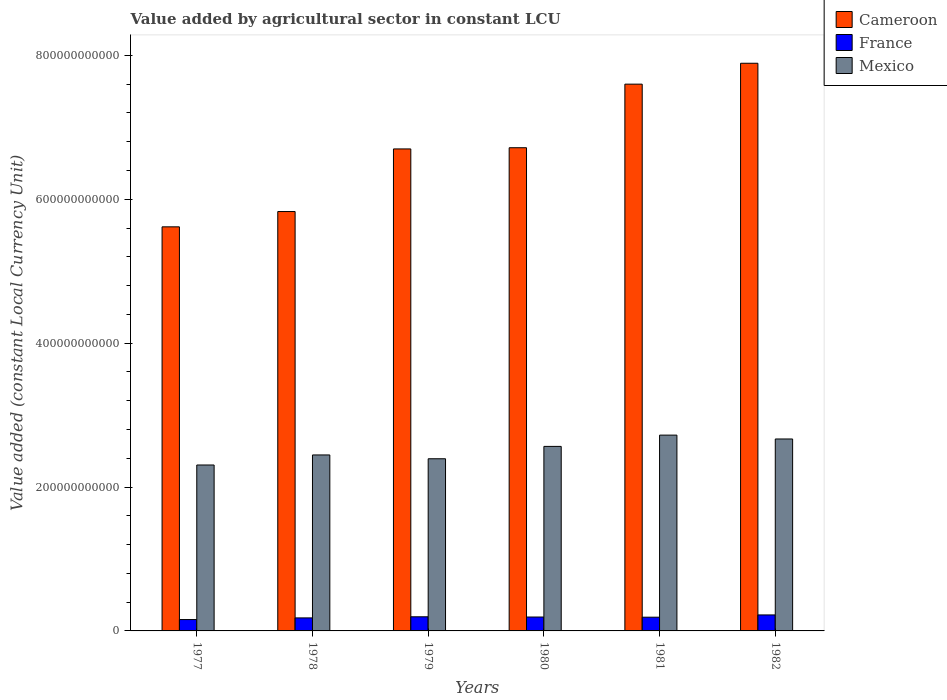Are the number of bars per tick equal to the number of legend labels?
Offer a very short reply. Yes. What is the label of the 5th group of bars from the left?
Your answer should be very brief. 1981. What is the value added by agricultural sector in France in 1980?
Your response must be concise. 1.93e+1. Across all years, what is the maximum value added by agricultural sector in Mexico?
Your answer should be compact. 2.72e+11. Across all years, what is the minimum value added by agricultural sector in Cameroon?
Offer a terse response. 5.62e+11. In which year was the value added by agricultural sector in Cameroon maximum?
Your answer should be compact. 1982. In which year was the value added by agricultural sector in Cameroon minimum?
Give a very brief answer. 1977. What is the total value added by agricultural sector in Cameroon in the graph?
Offer a terse response. 4.04e+12. What is the difference between the value added by agricultural sector in France in 1978 and that in 1982?
Your answer should be compact. -4.13e+09. What is the difference between the value added by agricultural sector in Mexico in 1982 and the value added by agricultural sector in Cameroon in 1978?
Provide a short and direct response. -3.16e+11. What is the average value added by agricultural sector in France per year?
Your response must be concise. 1.90e+1. In the year 1980, what is the difference between the value added by agricultural sector in France and value added by agricultural sector in Mexico?
Provide a succinct answer. -2.37e+11. In how many years, is the value added by agricultural sector in Cameroon greater than 280000000000 LCU?
Your answer should be compact. 6. What is the ratio of the value added by agricultural sector in France in 1979 to that in 1980?
Your answer should be compact. 1.02. Is the value added by agricultural sector in France in 1977 less than that in 1981?
Your answer should be compact. Yes. What is the difference between the highest and the second highest value added by agricultural sector in Mexico?
Provide a short and direct response. 5.36e+09. What is the difference between the highest and the lowest value added by agricultural sector in Cameroon?
Your answer should be very brief. 2.27e+11. In how many years, is the value added by agricultural sector in France greater than the average value added by agricultural sector in France taken over all years?
Offer a very short reply. 4. What does the 2nd bar from the right in 1981 represents?
Your answer should be compact. France. Are all the bars in the graph horizontal?
Your answer should be very brief. No. How many years are there in the graph?
Give a very brief answer. 6. What is the difference between two consecutive major ticks on the Y-axis?
Your response must be concise. 2.00e+11. Are the values on the major ticks of Y-axis written in scientific E-notation?
Your response must be concise. No. Does the graph contain grids?
Provide a short and direct response. No. Where does the legend appear in the graph?
Provide a succinct answer. Top right. How are the legend labels stacked?
Your response must be concise. Vertical. What is the title of the graph?
Provide a short and direct response. Value added by agricultural sector in constant LCU. Does "Suriname" appear as one of the legend labels in the graph?
Your response must be concise. No. What is the label or title of the X-axis?
Give a very brief answer. Years. What is the label or title of the Y-axis?
Give a very brief answer. Value added (constant Local Currency Unit). What is the Value added (constant Local Currency Unit) of Cameroon in 1977?
Ensure brevity in your answer.  5.62e+11. What is the Value added (constant Local Currency Unit) in France in 1977?
Give a very brief answer. 1.58e+1. What is the Value added (constant Local Currency Unit) of Mexico in 1977?
Your answer should be very brief. 2.31e+11. What is the Value added (constant Local Currency Unit) of Cameroon in 1978?
Offer a terse response. 5.83e+11. What is the Value added (constant Local Currency Unit) of France in 1978?
Your response must be concise. 1.81e+1. What is the Value added (constant Local Currency Unit) of Mexico in 1978?
Provide a short and direct response. 2.45e+11. What is the Value added (constant Local Currency Unit) of Cameroon in 1979?
Your response must be concise. 6.70e+11. What is the Value added (constant Local Currency Unit) of France in 1979?
Offer a very short reply. 1.96e+1. What is the Value added (constant Local Currency Unit) of Mexico in 1979?
Give a very brief answer. 2.39e+11. What is the Value added (constant Local Currency Unit) in Cameroon in 1980?
Offer a terse response. 6.72e+11. What is the Value added (constant Local Currency Unit) of France in 1980?
Offer a terse response. 1.93e+1. What is the Value added (constant Local Currency Unit) of Mexico in 1980?
Provide a succinct answer. 2.56e+11. What is the Value added (constant Local Currency Unit) in Cameroon in 1981?
Provide a succinct answer. 7.60e+11. What is the Value added (constant Local Currency Unit) of France in 1981?
Make the answer very short. 1.91e+1. What is the Value added (constant Local Currency Unit) in Mexico in 1981?
Give a very brief answer. 2.72e+11. What is the Value added (constant Local Currency Unit) in Cameroon in 1982?
Your answer should be very brief. 7.89e+11. What is the Value added (constant Local Currency Unit) of France in 1982?
Keep it short and to the point. 2.22e+1. What is the Value added (constant Local Currency Unit) in Mexico in 1982?
Make the answer very short. 2.67e+11. Across all years, what is the maximum Value added (constant Local Currency Unit) of Cameroon?
Ensure brevity in your answer.  7.89e+11. Across all years, what is the maximum Value added (constant Local Currency Unit) in France?
Your response must be concise. 2.22e+1. Across all years, what is the maximum Value added (constant Local Currency Unit) of Mexico?
Provide a succinct answer. 2.72e+11. Across all years, what is the minimum Value added (constant Local Currency Unit) of Cameroon?
Provide a short and direct response. 5.62e+11. Across all years, what is the minimum Value added (constant Local Currency Unit) of France?
Ensure brevity in your answer.  1.58e+1. Across all years, what is the minimum Value added (constant Local Currency Unit) in Mexico?
Your answer should be very brief. 2.31e+11. What is the total Value added (constant Local Currency Unit) in Cameroon in the graph?
Provide a succinct answer. 4.04e+12. What is the total Value added (constant Local Currency Unit) of France in the graph?
Your response must be concise. 1.14e+11. What is the total Value added (constant Local Currency Unit) of Mexico in the graph?
Provide a succinct answer. 1.51e+12. What is the difference between the Value added (constant Local Currency Unit) of Cameroon in 1977 and that in 1978?
Make the answer very short. -2.13e+1. What is the difference between the Value added (constant Local Currency Unit) of France in 1977 and that in 1978?
Your response must be concise. -2.31e+09. What is the difference between the Value added (constant Local Currency Unit) of Mexico in 1977 and that in 1978?
Keep it short and to the point. -1.40e+1. What is the difference between the Value added (constant Local Currency Unit) in Cameroon in 1977 and that in 1979?
Ensure brevity in your answer.  -1.08e+11. What is the difference between the Value added (constant Local Currency Unit) of France in 1977 and that in 1979?
Give a very brief answer. -3.84e+09. What is the difference between the Value added (constant Local Currency Unit) in Mexico in 1977 and that in 1979?
Provide a succinct answer. -8.68e+09. What is the difference between the Value added (constant Local Currency Unit) in Cameroon in 1977 and that in 1980?
Give a very brief answer. -1.10e+11. What is the difference between the Value added (constant Local Currency Unit) of France in 1977 and that in 1980?
Your answer should be very brief. -3.52e+09. What is the difference between the Value added (constant Local Currency Unit) in Mexico in 1977 and that in 1980?
Your answer should be compact. -2.58e+1. What is the difference between the Value added (constant Local Currency Unit) in Cameroon in 1977 and that in 1981?
Provide a short and direct response. -1.98e+11. What is the difference between the Value added (constant Local Currency Unit) of France in 1977 and that in 1981?
Provide a short and direct response. -3.29e+09. What is the difference between the Value added (constant Local Currency Unit) in Mexico in 1977 and that in 1981?
Offer a terse response. -4.15e+1. What is the difference between the Value added (constant Local Currency Unit) in Cameroon in 1977 and that in 1982?
Your answer should be compact. -2.27e+11. What is the difference between the Value added (constant Local Currency Unit) of France in 1977 and that in 1982?
Give a very brief answer. -6.44e+09. What is the difference between the Value added (constant Local Currency Unit) of Mexico in 1977 and that in 1982?
Provide a short and direct response. -3.62e+1. What is the difference between the Value added (constant Local Currency Unit) in Cameroon in 1978 and that in 1979?
Provide a succinct answer. -8.70e+1. What is the difference between the Value added (constant Local Currency Unit) in France in 1978 and that in 1979?
Give a very brief answer. -1.54e+09. What is the difference between the Value added (constant Local Currency Unit) in Mexico in 1978 and that in 1979?
Ensure brevity in your answer.  5.29e+09. What is the difference between the Value added (constant Local Currency Unit) of Cameroon in 1978 and that in 1980?
Keep it short and to the point. -8.87e+1. What is the difference between the Value added (constant Local Currency Unit) in France in 1978 and that in 1980?
Ensure brevity in your answer.  -1.21e+09. What is the difference between the Value added (constant Local Currency Unit) of Mexico in 1978 and that in 1980?
Your answer should be compact. -1.19e+1. What is the difference between the Value added (constant Local Currency Unit) in Cameroon in 1978 and that in 1981?
Your answer should be compact. -1.77e+11. What is the difference between the Value added (constant Local Currency Unit) of France in 1978 and that in 1981?
Your answer should be compact. -9.79e+08. What is the difference between the Value added (constant Local Currency Unit) in Mexico in 1978 and that in 1981?
Offer a very short reply. -2.76e+1. What is the difference between the Value added (constant Local Currency Unit) of Cameroon in 1978 and that in 1982?
Your answer should be compact. -2.06e+11. What is the difference between the Value added (constant Local Currency Unit) of France in 1978 and that in 1982?
Ensure brevity in your answer.  -4.13e+09. What is the difference between the Value added (constant Local Currency Unit) in Mexico in 1978 and that in 1982?
Provide a short and direct response. -2.22e+1. What is the difference between the Value added (constant Local Currency Unit) of Cameroon in 1979 and that in 1980?
Offer a very short reply. -1.66e+09. What is the difference between the Value added (constant Local Currency Unit) of France in 1979 and that in 1980?
Ensure brevity in your answer.  3.26e+08. What is the difference between the Value added (constant Local Currency Unit) in Mexico in 1979 and that in 1980?
Offer a very short reply. -1.72e+1. What is the difference between the Value added (constant Local Currency Unit) in Cameroon in 1979 and that in 1981?
Provide a short and direct response. -9.00e+1. What is the difference between the Value added (constant Local Currency Unit) of France in 1979 and that in 1981?
Make the answer very short. 5.57e+08. What is the difference between the Value added (constant Local Currency Unit) in Mexico in 1979 and that in 1981?
Ensure brevity in your answer.  -3.29e+1. What is the difference between the Value added (constant Local Currency Unit) in Cameroon in 1979 and that in 1982?
Your response must be concise. -1.19e+11. What is the difference between the Value added (constant Local Currency Unit) of France in 1979 and that in 1982?
Offer a very short reply. -2.59e+09. What is the difference between the Value added (constant Local Currency Unit) of Mexico in 1979 and that in 1982?
Your response must be concise. -2.75e+1. What is the difference between the Value added (constant Local Currency Unit) in Cameroon in 1980 and that in 1981?
Provide a short and direct response. -8.84e+1. What is the difference between the Value added (constant Local Currency Unit) of France in 1980 and that in 1981?
Provide a succinct answer. 2.31e+08. What is the difference between the Value added (constant Local Currency Unit) in Mexico in 1980 and that in 1981?
Offer a terse response. -1.57e+1. What is the difference between the Value added (constant Local Currency Unit) of Cameroon in 1980 and that in 1982?
Ensure brevity in your answer.  -1.17e+11. What is the difference between the Value added (constant Local Currency Unit) in France in 1980 and that in 1982?
Your answer should be compact. -2.92e+09. What is the difference between the Value added (constant Local Currency Unit) of Mexico in 1980 and that in 1982?
Offer a terse response. -1.03e+1. What is the difference between the Value added (constant Local Currency Unit) in Cameroon in 1981 and that in 1982?
Your answer should be compact. -2.90e+1. What is the difference between the Value added (constant Local Currency Unit) of France in 1981 and that in 1982?
Ensure brevity in your answer.  -3.15e+09. What is the difference between the Value added (constant Local Currency Unit) in Mexico in 1981 and that in 1982?
Make the answer very short. 5.36e+09. What is the difference between the Value added (constant Local Currency Unit) in Cameroon in 1977 and the Value added (constant Local Currency Unit) in France in 1978?
Keep it short and to the point. 5.44e+11. What is the difference between the Value added (constant Local Currency Unit) of Cameroon in 1977 and the Value added (constant Local Currency Unit) of Mexico in 1978?
Provide a short and direct response. 3.17e+11. What is the difference between the Value added (constant Local Currency Unit) of France in 1977 and the Value added (constant Local Currency Unit) of Mexico in 1978?
Keep it short and to the point. -2.29e+11. What is the difference between the Value added (constant Local Currency Unit) in Cameroon in 1977 and the Value added (constant Local Currency Unit) in France in 1979?
Offer a very short reply. 5.42e+11. What is the difference between the Value added (constant Local Currency Unit) of Cameroon in 1977 and the Value added (constant Local Currency Unit) of Mexico in 1979?
Provide a succinct answer. 3.22e+11. What is the difference between the Value added (constant Local Currency Unit) in France in 1977 and the Value added (constant Local Currency Unit) in Mexico in 1979?
Offer a very short reply. -2.24e+11. What is the difference between the Value added (constant Local Currency Unit) of Cameroon in 1977 and the Value added (constant Local Currency Unit) of France in 1980?
Provide a succinct answer. 5.42e+11. What is the difference between the Value added (constant Local Currency Unit) of Cameroon in 1977 and the Value added (constant Local Currency Unit) of Mexico in 1980?
Offer a very short reply. 3.05e+11. What is the difference between the Value added (constant Local Currency Unit) of France in 1977 and the Value added (constant Local Currency Unit) of Mexico in 1980?
Provide a short and direct response. -2.41e+11. What is the difference between the Value added (constant Local Currency Unit) of Cameroon in 1977 and the Value added (constant Local Currency Unit) of France in 1981?
Your answer should be compact. 5.43e+11. What is the difference between the Value added (constant Local Currency Unit) of Cameroon in 1977 and the Value added (constant Local Currency Unit) of Mexico in 1981?
Provide a succinct answer. 2.90e+11. What is the difference between the Value added (constant Local Currency Unit) in France in 1977 and the Value added (constant Local Currency Unit) in Mexico in 1981?
Your answer should be compact. -2.56e+11. What is the difference between the Value added (constant Local Currency Unit) in Cameroon in 1977 and the Value added (constant Local Currency Unit) in France in 1982?
Offer a terse response. 5.39e+11. What is the difference between the Value added (constant Local Currency Unit) in Cameroon in 1977 and the Value added (constant Local Currency Unit) in Mexico in 1982?
Provide a succinct answer. 2.95e+11. What is the difference between the Value added (constant Local Currency Unit) of France in 1977 and the Value added (constant Local Currency Unit) of Mexico in 1982?
Keep it short and to the point. -2.51e+11. What is the difference between the Value added (constant Local Currency Unit) of Cameroon in 1978 and the Value added (constant Local Currency Unit) of France in 1979?
Give a very brief answer. 5.63e+11. What is the difference between the Value added (constant Local Currency Unit) in Cameroon in 1978 and the Value added (constant Local Currency Unit) in Mexico in 1979?
Provide a succinct answer. 3.44e+11. What is the difference between the Value added (constant Local Currency Unit) in France in 1978 and the Value added (constant Local Currency Unit) in Mexico in 1979?
Keep it short and to the point. -2.21e+11. What is the difference between the Value added (constant Local Currency Unit) of Cameroon in 1978 and the Value added (constant Local Currency Unit) of France in 1980?
Your answer should be compact. 5.64e+11. What is the difference between the Value added (constant Local Currency Unit) of Cameroon in 1978 and the Value added (constant Local Currency Unit) of Mexico in 1980?
Provide a short and direct response. 3.26e+11. What is the difference between the Value added (constant Local Currency Unit) of France in 1978 and the Value added (constant Local Currency Unit) of Mexico in 1980?
Offer a terse response. -2.38e+11. What is the difference between the Value added (constant Local Currency Unit) in Cameroon in 1978 and the Value added (constant Local Currency Unit) in France in 1981?
Your answer should be very brief. 5.64e+11. What is the difference between the Value added (constant Local Currency Unit) in Cameroon in 1978 and the Value added (constant Local Currency Unit) in Mexico in 1981?
Provide a short and direct response. 3.11e+11. What is the difference between the Value added (constant Local Currency Unit) of France in 1978 and the Value added (constant Local Currency Unit) of Mexico in 1981?
Your response must be concise. -2.54e+11. What is the difference between the Value added (constant Local Currency Unit) of Cameroon in 1978 and the Value added (constant Local Currency Unit) of France in 1982?
Your answer should be compact. 5.61e+11. What is the difference between the Value added (constant Local Currency Unit) in Cameroon in 1978 and the Value added (constant Local Currency Unit) in Mexico in 1982?
Your response must be concise. 3.16e+11. What is the difference between the Value added (constant Local Currency Unit) of France in 1978 and the Value added (constant Local Currency Unit) of Mexico in 1982?
Your response must be concise. -2.49e+11. What is the difference between the Value added (constant Local Currency Unit) of Cameroon in 1979 and the Value added (constant Local Currency Unit) of France in 1980?
Keep it short and to the point. 6.51e+11. What is the difference between the Value added (constant Local Currency Unit) of Cameroon in 1979 and the Value added (constant Local Currency Unit) of Mexico in 1980?
Your answer should be very brief. 4.14e+11. What is the difference between the Value added (constant Local Currency Unit) in France in 1979 and the Value added (constant Local Currency Unit) in Mexico in 1980?
Your answer should be compact. -2.37e+11. What is the difference between the Value added (constant Local Currency Unit) in Cameroon in 1979 and the Value added (constant Local Currency Unit) in France in 1981?
Ensure brevity in your answer.  6.51e+11. What is the difference between the Value added (constant Local Currency Unit) of Cameroon in 1979 and the Value added (constant Local Currency Unit) of Mexico in 1981?
Give a very brief answer. 3.98e+11. What is the difference between the Value added (constant Local Currency Unit) of France in 1979 and the Value added (constant Local Currency Unit) of Mexico in 1981?
Offer a very short reply. -2.53e+11. What is the difference between the Value added (constant Local Currency Unit) in Cameroon in 1979 and the Value added (constant Local Currency Unit) in France in 1982?
Your answer should be very brief. 6.48e+11. What is the difference between the Value added (constant Local Currency Unit) of Cameroon in 1979 and the Value added (constant Local Currency Unit) of Mexico in 1982?
Your response must be concise. 4.03e+11. What is the difference between the Value added (constant Local Currency Unit) in France in 1979 and the Value added (constant Local Currency Unit) in Mexico in 1982?
Provide a short and direct response. -2.47e+11. What is the difference between the Value added (constant Local Currency Unit) in Cameroon in 1980 and the Value added (constant Local Currency Unit) in France in 1981?
Provide a short and direct response. 6.53e+11. What is the difference between the Value added (constant Local Currency Unit) of Cameroon in 1980 and the Value added (constant Local Currency Unit) of Mexico in 1981?
Keep it short and to the point. 3.99e+11. What is the difference between the Value added (constant Local Currency Unit) in France in 1980 and the Value added (constant Local Currency Unit) in Mexico in 1981?
Offer a very short reply. -2.53e+11. What is the difference between the Value added (constant Local Currency Unit) in Cameroon in 1980 and the Value added (constant Local Currency Unit) in France in 1982?
Your answer should be very brief. 6.49e+11. What is the difference between the Value added (constant Local Currency Unit) of Cameroon in 1980 and the Value added (constant Local Currency Unit) of Mexico in 1982?
Give a very brief answer. 4.05e+11. What is the difference between the Value added (constant Local Currency Unit) in France in 1980 and the Value added (constant Local Currency Unit) in Mexico in 1982?
Your response must be concise. -2.48e+11. What is the difference between the Value added (constant Local Currency Unit) of Cameroon in 1981 and the Value added (constant Local Currency Unit) of France in 1982?
Your answer should be very brief. 7.38e+11. What is the difference between the Value added (constant Local Currency Unit) in Cameroon in 1981 and the Value added (constant Local Currency Unit) in Mexico in 1982?
Your answer should be very brief. 4.93e+11. What is the difference between the Value added (constant Local Currency Unit) in France in 1981 and the Value added (constant Local Currency Unit) in Mexico in 1982?
Provide a succinct answer. -2.48e+11. What is the average Value added (constant Local Currency Unit) in Cameroon per year?
Provide a succinct answer. 6.73e+11. What is the average Value added (constant Local Currency Unit) in France per year?
Make the answer very short. 1.90e+1. What is the average Value added (constant Local Currency Unit) in Mexico per year?
Offer a very short reply. 2.52e+11. In the year 1977, what is the difference between the Value added (constant Local Currency Unit) in Cameroon and Value added (constant Local Currency Unit) in France?
Keep it short and to the point. 5.46e+11. In the year 1977, what is the difference between the Value added (constant Local Currency Unit) of Cameroon and Value added (constant Local Currency Unit) of Mexico?
Provide a succinct answer. 3.31e+11. In the year 1977, what is the difference between the Value added (constant Local Currency Unit) in France and Value added (constant Local Currency Unit) in Mexico?
Your answer should be very brief. -2.15e+11. In the year 1978, what is the difference between the Value added (constant Local Currency Unit) of Cameroon and Value added (constant Local Currency Unit) of France?
Make the answer very short. 5.65e+11. In the year 1978, what is the difference between the Value added (constant Local Currency Unit) of Cameroon and Value added (constant Local Currency Unit) of Mexico?
Keep it short and to the point. 3.38e+11. In the year 1978, what is the difference between the Value added (constant Local Currency Unit) in France and Value added (constant Local Currency Unit) in Mexico?
Your answer should be compact. -2.27e+11. In the year 1979, what is the difference between the Value added (constant Local Currency Unit) in Cameroon and Value added (constant Local Currency Unit) in France?
Keep it short and to the point. 6.50e+11. In the year 1979, what is the difference between the Value added (constant Local Currency Unit) of Cameroon and Value added (constant Local Currency Unit) of Mexico?
Offer a terse response. 4.31e+11. In the year 1979, what is the difference between the Value added (constant Local Currency Unit) in France and Value added (constant Local Currency Unit) in Mexico?
Provide a short and direct response. -2.20e+11. In the year 1980, what is the difference between the Value added (constant Local Currency Unit) in Cameroon and Value added (constant Local Currency Unit) in France?
Give a very brief answer. 6.52e+11. In the year 1980, what is the difference between the Value added (constant Local Currency Unit) of Cameroon and Value added (constant Local Currency Unit) of Mexico?
Your answer should be compact. 4.15e+11. In the year 1980, what is the difference between the Value added (constant Local Currency Unit) of France and Value added (constant Local Currency Unit) of Mexico?
Ensure brevity in your answer.  -2.37e+11. In the year 1981, what is the difference between the Value added (constant Local Currency Unit) of Cameroon and Value added (constant Local Currency Unit) of France?
Ensure brevity in your answer.  7.41e+11. In the year 1981, what is the difference between the Value added (constant Local Currency Unit) of Cameroon and Value added (constant Local Currency Unit) of Mexico?
Provide a succinct answer. 4.88e+11. In the year 1981, what is the difference between the Value added (constant Local Currency Unit) in France and Value added (constant Local Currency Unit) in Mexico?
Your answer should be very brief. -2.53e+11. In the year 1982, what is the difference between the Value added (constant Local Currency Unit) in Cameroon and Value added (constant Local Currency Unit) in France?
Ensure brevity in your answer.  7.67e+11. In the year 1982, what is the difference between the Value added (constant Local Currency Unit) in Cameroon and Value added (constant Local Currency Unit) in Mexico?
Your response must be concise. 5.22e+11. In the year 1982, what is the difference between the Value added (constant Local Currency Unit) in France and Value added (constant Local Currency Unit) in Mexico?
Offer a terse response. -2.45e+11. What is the ratio of the Value added (constant Local Currency Unit) in Cameroon in 1977 to that in 1978?
Offer a very short reply. 0.96. What is the ratio of the Value added (constant Local Currency Unit) of France in 1977 to that in 1978?
Provide a succinct answer. 0.87. What is the ratio of the Value added (constant Local Currency Unit) in Mexico in 1977 to that in 1978?
Your answer should be very brief. 0.94. What is the ratio of the Value added (constant Local Currency Unit) of Cameroon in 1977 to that in 1979?
Keep it short and to the point. 0.84. What is the ratio of the Value added (constant Local Currency Unit) in France in 1977 to that in 1979?
Offer a terse response. 0.8. What is the ratio of the Value added (constant Local Currency Unit) in Mexico in 1977 to that in 1979?
Provide a short and direct response. 0.96. What is the ratio of the Value added (constant Local Currency Unit) in Cameroon in 1977 to that in 1980?
Your response must be concise. 0.84. What is the ratio of the Value added (constant Local Currency Unit) in France in 1977 to that in 1980?
Provide a succinct answer. 0.82. What is the ratio of the Value added (constant Local Currency Unit) of Mexico in 1977 to that in 1980?
Your answer should be very brief. 0.9. What is the ratio of the Value added (constant Local Currency Unit) in Cameroon in 1977 to that in 1981?
Provide a succinct answer. 0.74. What is the ratio of the Value added (constant Local Currency Unit) in France in 1977 to that in 1981?
Offer a very short reply. 0.83. What is the ratio of the Value added (constant Local Currency Unit) of Mexico in 1977 to that in 1981?
Provide a short and direct response. 0.85. What is the ratio of the Value added (constant Local Currency Unit) in Cameroon in 1977 to that in 1982?
Make the answer very short. 0.71. What is the ratio of the Value added (constant Local Currency Unit) in France in 1977 to that in 1982?
Offer a very short reply. 0.71. What is the ratio of the Value added (constant Local Currency Unit) in Mexico in 1977 to that in 1982?
Offer a very short reply. 0.86. What is the ratio of the Value added (constant Local Currency Unit) of Cameroon in 1978 to that in 1979?
Provide a succinct answer. 0.87. What is the ratio of the Value added (constant Local Currency Unit) in France in 1978 to that in 1979?
Make the answer very short. 0.92. What is the ratio of the Value added (constant Local Currency Unit) in Mexico in 1978 to that in 1979?
Your answer should be very brief. 1.02. What is the ratio of the Value added (constant Local Currency Unit) in Cameroon in 1978 to that in 1980?
Give a very brief answer. 0.87. What is the ratio of the Value added (constant Local Currency Unit) of France in 1978 to that in 1980?
Provide a short and direct response. 0.94. What is the ratio of the Value added (constant Local Currency Unit) in Mexico in 1978 to that in 1980?
Ensure brevity in your answer.  0.95. What is the ratio of the Value added (constant Local Currency Unit) in Cameroon in 1978 to that in 1981?
Provide a short and direct response. 0.77. What is the ratio of the Value added (constant Local Currency Unit) in France in 1978 to that in 1981?
Offer a very short reply. 0.95. What is the ratio of the Value added (constant Local Currency Unit) of Mexico in 1978 to that in 1981?
Give a very brief answer. 0.9. What is the ratio of the Value added (constant Local Currency Unit) in Cameroon in 1978 to that in 1982?
Give a very brief answer. 0.74. What is the ratio of the Value added (constant Local Currency Unit) in France in 1978 to that in 1982?
Offer a very short reply. 0.81. What is the ratio of the Value added (constant Local Currency Unit) in Mexico in 1978 to that in 1982?
Provide a short and direct response. 0.92. What is the ratio of the Value added (constant Local Currency Unit) of Cameroon in 1979 to that in 1980?
Offer a very short reply. 1. What is the ratio of the Value added (constant Local Currency Unit) of France in 1979 to that in 1980?
Your response must be concise. 1.02. What is the ratio of the Value added (constant Local Currency Unit) in Mexico in 1979 to that in 1980?
Offer a very short reply. 0.93. What is the ratio of the Value added (constant Local Currency Unit) in Cameroon in 1979 to that in 1981?
Give a very brief answer. 0.88. What is the ratio of the Value added (constant Local Currency Unit) of France in 1979 to that in 1981?
Your answer should be very brief. 1.03. What is the ratio of the Value added (constant Local Currency Unit) of Mexico in 1979 to that in 1981?
Your answer should be very brief. 0.88. What is the ratio of the Value added (constant Local Currency Unit) in Cameroon in 1979 to that in 1982?
Give a very brief answer. 0.85. What is the ratio of the Value added (constant Local Currency Unit) of France in 1979 to that in 1982?
Make the answer very short. 0.88. What is the ratio of the Value added (constant Local Currency Unit) in Mexico in 1979 to that in 1982?
Give a very brief answer. 0.9. What is the ratio of the Value added (constant Local Currency Unit) in Cameroon in 1980 to that in 1981?
Offer a very short reply. 0.88. What is the ratio of the Value added (constant Local Currency Unit) of France in 1980 to that in 1981?
Your answer should be compact. 1.01. What is the ratio of the Value added (constant Local Currency Unit) in Mexico in 1980 to that in 1981?
Your answer should be compact. 0.94. What is the ratio of the Value added (constant Local Currency Unit) in Cameroon in 1980 to that in 1982?
Ensure brevity in your answer.  0.85. What is the ratio of the Value added (constant Local Currency Unit) in France in 1980 to that in 1982?
Provide a short and direct response. 0.87. What is the ratio of the Value added (constant Local Currency Unit) of Mexico in 1980 to that in 1982?
Make the answer very short. 0.96. What is the ratio of the Value added (constant Local Currency Unit) in Cameroon in 1981 to that in 1982?
Keep it short and to the point. 0.96. What is the ratio of the Value added (constant Local Currency Unit) of France in 1981 to that in 1982?
Provide a succinct answer. 0.86. What is the ratio of the Value added (constant Local Currency Unit) in Mexico in 1981 to that in 1982?
Provide a succinct answer. 1.02. What is the difference between the highest and the second highest Value added (constant Local Currency Unit) of Cameroon?
Your response must be concise. 2.90e+1. What is the difference between the highest and the second highest Value added (constant Local Currency Unit) in France?
Your response must be concise. 2.59e+09. What is the difference between the highest and the second highest Value added (constant Local Currency Unit) in Mexico?
Ensure brevity in your answer.  5.36e+09. What is the difference between the highest and the lowest Value added (constant Local Currency Unit) of Cameroon?
Make the answer very short. 2.27e+11. What is the difference between the highest and the lowest Value added (constant Local Currency Unit) of France?
Your answer should be very brief. 6.44e+09. What is the difference between the highest and the lowest Value added (constant Local Currency Unit) in Mexico?
Ensure brevity in your answer.  4.15e+1. 